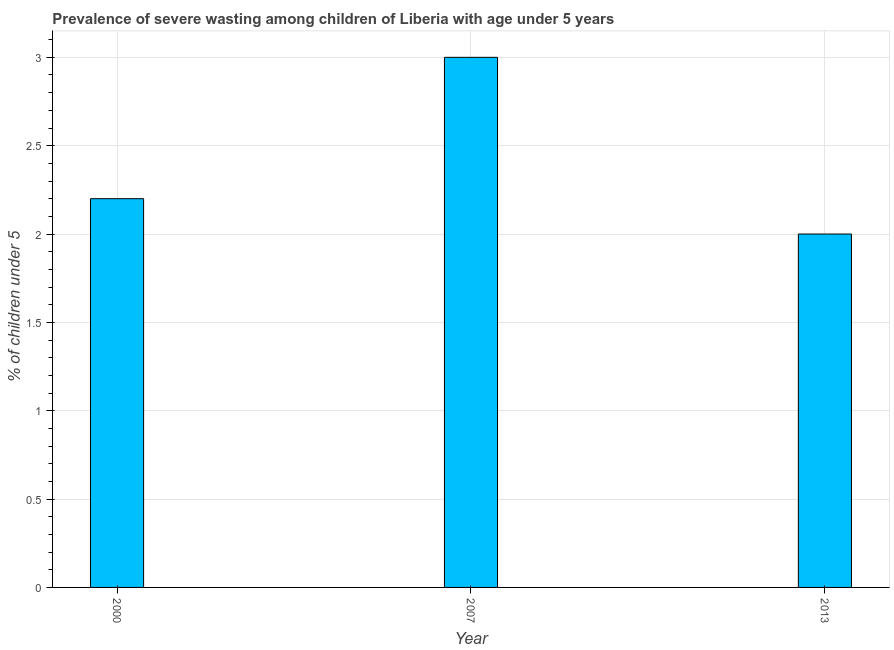Does the graph contain any zero values?
Ensure brevity in your answer.  No. Does the graph contain grids?
Your response must be concise. Yes. What is the title of the graph?
Offer a terse response. Prevalence of severe wasting among children of Liberia with age under 5 years. What is the label or title of the Y-axis?
Your answer should be compact.  % of children under 5. What is the prevalence of severe wasting in 2000?
Provide a short and direct response. 2.2. Across all years, what is the maximum prevalence of severe wasting?
Ensure brevity in your answer.  3. Across all years, what is the minimum prevalence of severe wasting?
Your answer should be very brief. 2. What is the sum of the prevalence of severe wasting?
Give a very brief answer. 7.2. What is the median prevalence of severe wasting?
Your response must be concise. 2.2. In how many years, is the prevalence of severe wasting greater than 0.4 %?
Give a very brief answer. 3. Is the prevalence of severe wasting in 2007 less than that in 2013?
Offer a terse response. No. Is the difference between the prevalence of severe wasting in 2000 and 2013 greater than the difference between any two years?
Your answer should be very brief. No. Is the sum of the prevalence of severe wasting in 2000 and 2013 greater than the maximum prevalence of severe wasting across all years?
Your answer should be compact. Yes. What is the difference between the highest and the lowest prevalence of severe wasting?
Provide a succinct answer. 1. How many years are there in the graph?
Make the answer very short. 3. Are the values on the major ticks of Y-axis written in scientific E-notation?
Offer a terse response. No. What is the  % of children under 5 of 2000?
Offer a terse response. 2.2. What is the difference between the  % of children under 5 in 2000 and 2007?
Give a very brief answer. -0.8. What is the ratio of the  % of children under 5 in 2000 to that in 2007?
Give a very brief answer. 0.73. What is the ratio of the  % of children under 5 in 2000 to that in 2013?
Provide a short and direct response. 1.1. 